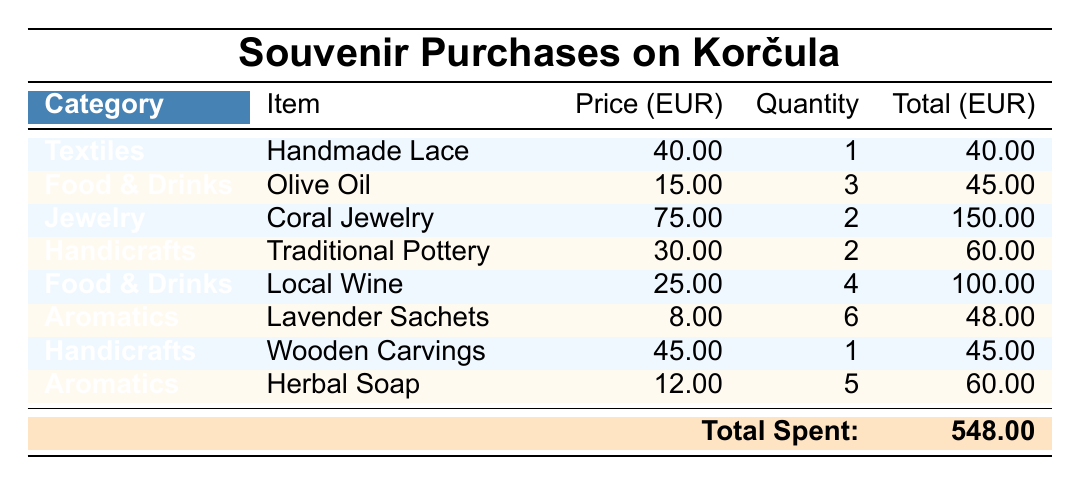What is the total amount spent on jewelry? To find the total amount spent on jewelry, we need to calculate the total for items in the Jewelry category. The item "Coral Jewelry" has a price of 75 EUR and a quantity of 2, so the total is 75 * 2 = 150 EUR.
Answer: 150 EUR How many lavender sachets were purchased? The table lists the item "Lavender Sachets," which has a quantity of 6. Therefore, the answer is directly taken from this row.
Answer: 6 What is the average price of food and drink items purchased? In the Food & Drinks category, the items are "Olive Oil" (15 EUR), "Local Wine" (25 EUR). The total price is 15 + 25 = 40 EUR for a total of 2 items. To find the average, we divide the total price by the number of items: 40 EUR / 2 = 20 EUR.
Answer: 20 EUR Did the tourist purchase more items in handicrafts than in aromatics? There are 2 items listed in the Handicrafts category: "Traditional Pottery" (quantity 2) and "Wooden Carvings" (quantity 1) for a total of 3 items. In the Aromatics category, there are also 2 items: "Lavender Sachets" (quantity 6) and "Herbal Soap" (quantity 5) for a total of 11 items. Since 3 (handicrafts) is not greater than 11 (aromatics), the answer is "No."
Answer: No What is the total spending on textiles? The only item in the Textiles category is "Handmade Lace," which costs 40 EUR with a quantity of 1. Thus, total spending is directly calculated as 40 * 1 = 40 EUR.
Answer: 40 EUR 